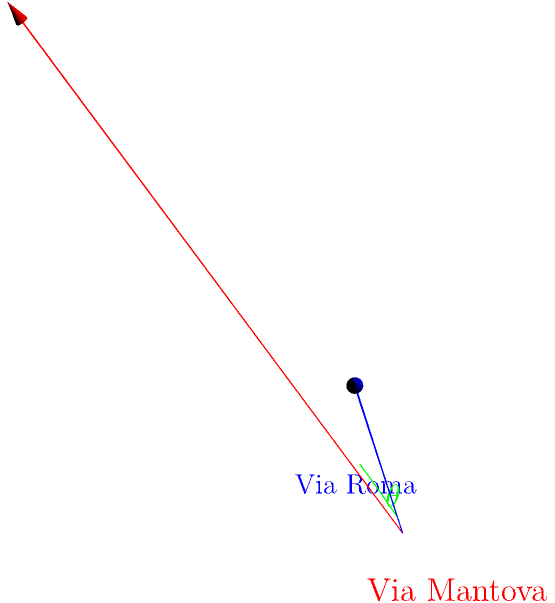As part of a city planning project in Mantua, you need to determine the angle between two intersecting streets: Via Roma and Via Mantova. Given that Via Roma can be represented by the vector $\vec{a} = \langle 3, 1, 2 \rangle$ and Via Mantova by the vector $\vec{b} = \langle 2, -1, 3 \rangle$, calculate the angle $\theta$ between these two streets. To find the angle between two vectors in 3D space, we can use the dot product formula:

$$\cos \theta = \frac{\vec{a} \cdot \vec{b}}{|\vec{a}||\vec{b}|}$$

Step 1: Calculate the dot product $\vec{a} \cdot \vec{b}$
$$\vec{a} \cdot \vec{b} = (3)(2) + (1)(-1) + (2)(3) = 6 - 1 + 6 = 11$$

Step 2: Calculate the magnitudes of $\vec{a}$ and $\vec{b}$
$$|\vec{a}| = \sqrt{3^2 + 1^2 + 2^2} = \sqrt{14}$$
$$|\vec{b}| = \sqrt{2^2 + (-1)^2 + 3^2} = \sqrt{14}$$

Step 3: Substitute into the formula
$$\cos \theta = \frac{11}{\sqrt{14}\sqrt{14}} = \frac{11}{14}$$

Step 4: Take the inverse cosine (arccos) of both sides
$$\theta = \arccos(\frac{11}{14})$$

Step 5: Calculate the result
$$\theta \approx 0.8391 \text{ radians} \approx 48.09°$$
Answer: $48.09°$ 